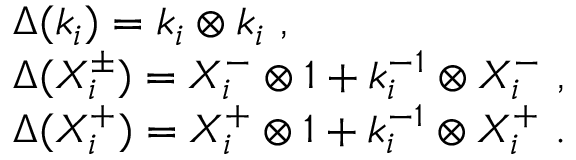<formula> <loc_0><loc_0><loc_500><loc_500>\begin{array} { r c l & { { \Delta ( k _ { i } ) = k _ { i } \otimes k _ { i } , } } & { { \Delta ( X _ { i } ^ { \pm } ) = X _ { i } ^ { - } \otimes 1 + k _ { i } ^ { - 1 } \otimes X _ { i } ^ { - } , } } & { { \Delta ( X _ { i } ^ { + } ) = X _ { i } ^ { + } \otimes 1 + k _ { i } ^ { - 1 } \otimes X _ { i } ^ { + } . } } \end{array}</formula> 